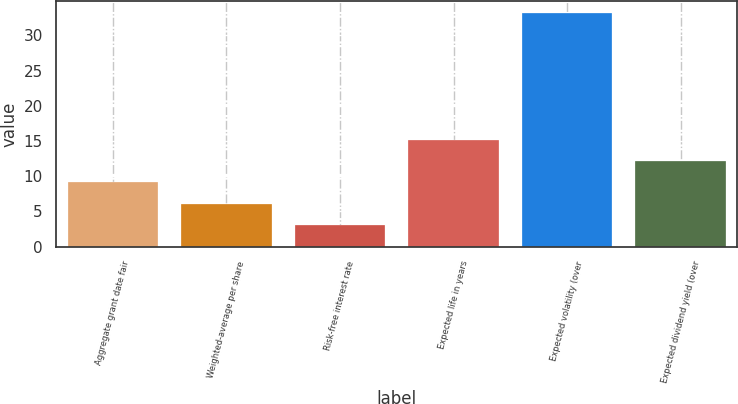<chart> <loc_0><loc_0><loc_500><loc_500><bar_chart><fcel>Aggregate grant date fair<fcel>Weighted-average per share<fcel>Risk-free interest rate<fcel>Expected life in years<fcel>Expected volatility (over<fcel>Expected dividend yield (over<nl><fcel>9.12<fcel>6.11<fcel>3.1<fcel>15.14<fcel>33.2<fcel>12.13<nl></chart> 